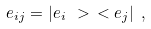Convert formula to latex. <formula><loc_0><loc_0><loc_500><loc_500>e _ { i j } = | e _ { i } \ > \ < e _ { j } | \ ,</formula> 